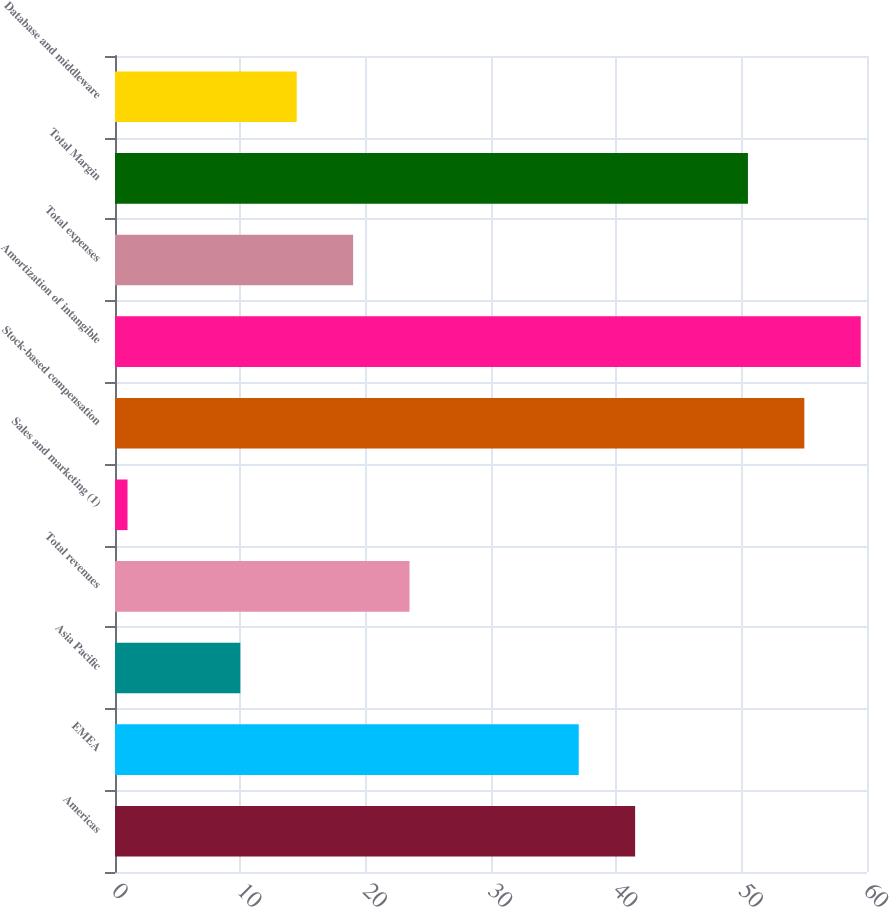Convert chart. <chart><loc_0><loc_0><loc_500><loc_500><bar_chart><fcel>Americas<fcel>EMEA<fcel>Asia Pacific<fcel>Total revenues<fcel>Sales and marketing (1)<fcel>Stock-based compensation<fcel>Amortization of intangible<fcel>Total expenses<fcel>Total Margin<fcel>Database and middleware<nl><fcel>41.5<fcel>37<fcel>10<fcel>23.5<fcel>1<fcel>55<fcel>59.5<fcel>19<fcel>50.5<fcel>14.5<nl></chart> 